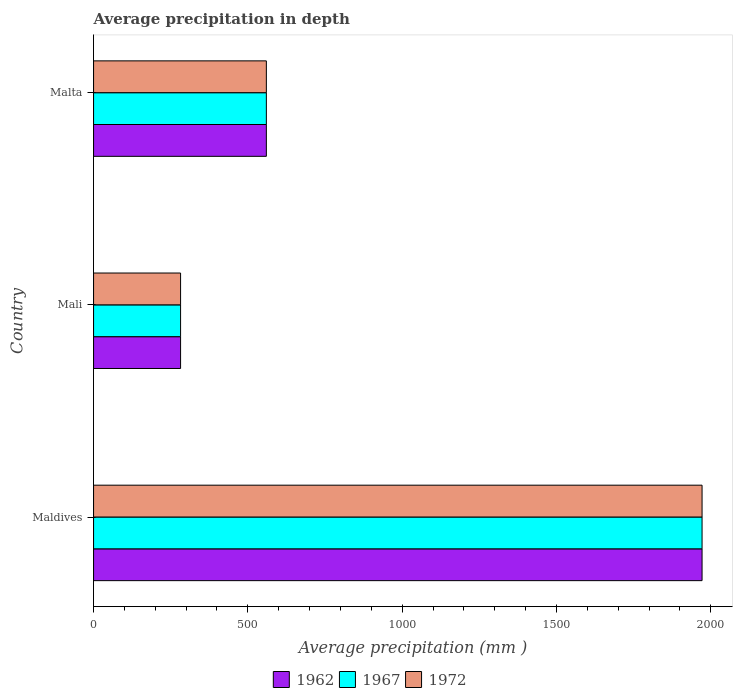Are the number of bars per tick equal to the number of legend labels?
Provide a short and direct response. Yes. How many bars are there on the 2nd tick from the top?
Make the answer very short. 3. How many bars are there on the 1st tick from the bottom?
Provide a succinct answer. 3. What is the label of the 3rd group of bars from the top?
Your answer should be compact. Maldives. What is the average precipitation in 1972 in Maldives?
Your response must be concise. 1972. Across all countries, what is the maximum average precipitation in 1972?
Your response must be concise. 1972. Across all countries, what is the minimum average precipitation in 1972?
Offer a very short reply. 282. In which country was the average precipitation in 1962 maximum?
Offer a terse response. Maldives. In which country was the average precipitation in 1967 minimum?
Offer a very short reply. Mali. What is the total average precipitation in 1962 in the graph?
Offer a very short reply. 2814. What is the difference between the average precipitation in 1967 in Maldives and that in Malta?
Provide a succinct answer. 1412. What is the difference between the average precipitation in 1972 in Malta and the average precipitation in 1962 in Maldives?
Ensure brevity in your answer.  -1412. What is the average average precipitation in 1967 per country?
Keep it short and to the point. 938. What is the difference between the average precipitation in 1972 and average precipitation in 1962 in Malta?
Provide a short and direct response. 0. What is the ratio of the average precipitation in 1962 in Maldives to that in Malta?
Offer a very short reply. 3.52. Is the average precipitation in 1962 in Maldives less than that in Malta?
Offer a very short reply. No. Is the difference between the average precipitation in 1972 in Maldives and Malta greater than the difference between the average precipitation in 1962 in Maldives and Malta?
Your answer should be compact. No. What is the difference between the highest and the second highest average precipitation in 1967?
Your response must be concise. 1412. What is the difference between the highest and the lowest average precipitation in 1962?
Your answer should be very brief. 1690. In how many countries, is the average precipitation in 1967 greater than the average average precipitation in 1967 taken over all countries?
Your response must be concise. 1. Is the sum of the average precipitation in 1962 in Maldives and Malta greater than the maximum average precipitation in 1967 across all countries?
Keep it short and to the point. Yes. What does the 3rd bar from the top in Malta represents?
Provide a succinct answer. 1962. Is it the case that in every country, the sum of the average precipitation in 1972 and average precipitation in 1967 is greater than the average precipitation in 1962?
Ensure brevity in your answer.  Yes. How many bars are there?
Give a very brief answer. 9. Are all the bars in the graph horizontal?
Ensure brevity in your answer.  Yes. Are the values on the major ticks of X-axis written in scientific E-notation?
Offer a very short reply. No. Does the graph contain any zero values?
Your answer should be very brief. No. How many legend labels are there?
Ensure brevity in your answer.  3. How are the legend labels stacked?
Your answer should be compact. Horizontal. What is the title of the graph?
Offer a terse response. Average precipitation in depth. Does "2014" appear as one of the legend labels in the graph?
Make the answer very short. No. What is the label or title of the X-axis?
Make the answer very short. Average precipitation (mm ). What is the Average precipitation (mm ) in 1962 in Maldives?
Your answer should be very brief. 1972. What is the Average precipitation (mm ) in 1967 in Maldives?
Provide a short and direct response. 1972. What is the Average precipitation (mm ) of 1972 in Maldives?
Your response must be concise. 1972. What is the Average precipitation (mm ) of 1962 in Mali?
Your answer should be very brief. 282. What is the Average precipitation (mm ) in 1967 in Mali?
Your answer should be very brief. 282. What is the Average precipitation (mm ) of 1972 in Mali?
Keep it short and to the point. 282. What is the Average precipitation (mm ) in 1962 in Malta?
Your response must be concise. 560. What is the Average precipitation (mm ) of 1967 in Malta?
Your answer should be compact. 560. What is the Average precipitation (mm ) in 1972 in Malta?
Offer a very short reply. 560. Across all countries, what is the maximum Average precipitation (mm ) in 1962?
Your answer should be very brief. 1972. Across all countries, what is the maximum Average precipitation (mm ) of 1967?
Offer a terse response. 1972. Across all countries, what is the maximum Average precipitation (mm ) of 1972?
Keep it short and to the point. 1972. Across all countries, what is the minimum Average precipitation (mm ) in 1962?
Provide a succinct answer. 282. Across all countries, what is the minimum Average precipitation (mm ) of 1967?
Keep it short and to the point. 282. Across all countries, what is the minimum Average precipitation (mm ) in 1972?
Your answer should be very brief. 282. What is the total Average precipitation (mm ) of 1962 in the graph?
Ensure brevity in your answer.  2814. What is the total Average precipitation (mm ) in 1967 in the graph?
Your answer should be very brief. 2814. What is the total Average precipitation (mm ) in 1972 in the graph?
Offer a terse response. 2814. What is the difference between the Average precipitation (mm ) in 1962 in Maldives and that in Mali?
Offer a very short reply. 1690. What is the difference between the Average precipitation (mm ) of 1967 in Maldives and that in Mali?
Make the answer very short. 1690. What is the difference between the Average precipitation (mm ) of 1972 in Maldives and that in Mali?
Provide a short and direct response. 1690. What is the difference between the Average precipitation (mm ) of 1962 in Maldives and that in Malta?
Your answer should be compact. 1412. What is the difference between the Average precipitation (mm ) in 1967 in Maldives and that in Malta?
Provide a succinct answer. 1412. What is the difference between the Average precipitation (mm ) of 1972 in Maldives and that in Malta?
Offer a very short reply. 1412. What is the difference between the Average precipitation (mm ) of 1962 in Mali and that in Malta?
Offer a very short reply. -278. What is the difference between the Average precipitation (mm ) in 1967 in Mali and that in Malta?
Offer a terse response. -278. What is the difference between the Average precipitation (mm ) in 1972 in Mali and that in Malta?
Your answer should be very brief. -278. What is the difference between the Average precipitation (mm ) of 1962 in Maldives and the Average precipitation (mm ) of 1967 in Mali?
Your answer should be compact. 1690. What is the difference between the Average precipitation (mm ) of 1962 in Maldives and the Average precipitation (mm ) of 1972 in Mali?
Provide a short and direct response. 1690. What is the difference between the Average precipitation (mm ) in 1967 in Maldives and the Average precipitation (mm ) in 1972 in Mali?
Your answer should be very brief. 1690. What is the difference between the Average precipitation (mm ) of 1962 in Maldives and the Average precipitation (mm ) of 1967 in Malta?
Provide a succinct answer. 1412. What is the difference between the Average precipitation (mm ) of 1962 in Maldives and the Average precipitation (mm ) of 1972 in Malta?
Give a very brief answer. 1412. What is the difference between the Average precipitation (mm ) of 1967 in Maldives and the Average precipitation (mm ) of 1972 in Malta?
Offer a terse response. 1412. What is the difference between the Average precipitation (mm ) of 1962 in Mali and the Average precipitation (mm ) of 1967 in Malta?
Your response must be concise. -278. What is the difference between the Average precipitation (mm ) of 1962 in Mali and the Average precipitation (mm ) of 1972 in Malta?
Your response must be concise. -278. What is the difference between the Average precipitation (mm ) in 1967 in Mali and the Average precipitation (mm ) in 1972 in Malta?
Give a very brief answer. -278. What is the average Average precipitation (mm ) in 1962 per country?
Your answer should be very brief. 938. What is the average Average precipitation (mm ) in 1967 per country?
Give a very brief answer. 938. What is the average Average precipitation (mm ) of 1972 per country?
Your answer should be compact. 938. What is the difference between the Average precipitation (mm ) in 1962 and Average precipitation (mm ) in 1967 in Maldives?
Provide a succinct answer. 0. What is the difference between the Average precipitation (mm ) in 1967 and Average precipitation (mm ) in 1972 in Mali?
Make the answer very short. 0. What is the difference between the Average precipitation (mm ) in 1967 and Average precipitation (mm ) in 1972 in Malta?
Ensure brevity in your answer.  0. What is the ratio of the Average precipitation (mm ) of 1962 in Maldives to that in Mali?
Your answer should be compact. 6.99. What is the ratio of the Average precipitation (mm ) of 1967 in Maldives to that in Mali?
Provide a succinct answer. 6.99. What is the ratio of the Average precipitation (mm ) in 1972 in Maldives to that in Mali?
Keep it short and to the point. 6.99. What is the ratio of the Average precipitation (mm ) in 1962 in Maldives to that in Malta?
Offer a very short reply. 3.52. What is the ratio of the Average precipitation (mm ) in 1967 in Maldives to that in Malta?
Give a very brief answer. 3.52. What is the ratio of the Average precipitation (mm ) of 1972 in Maldives to that in Malta?
Ensure brevity in your answer.  3.52. What is the ratio of the Average precipitation (mm ) in 1962 in Mali to that in Malta?
Keep it short and to the point. 0.5. What is the ratio of the Average precipitation (mm ) of 1967 in Mali to that in Malta?
Provide a succinct answer. 0.5. What is the ratio of the Average precipitation (mm ) in 1972 in Mali to that in Malta?
Provide a succinct answer. 0.5. What is the difference between the highest and the second highest Average precipitation (mm ) in 1962?
Your response must be concise. 1412. What is the difference between the highest and the second highest Average precipitation (mm ) of 1967?
Give a very brief answer. 1412. What is the difference between the highest and the second highest Average precipitation (mm ) in 1972?
Provide a succinct answer. 1412. What is the difference between the highest and the lowest Average precipitation (mm ) of 1962?
Provide a short and direct response. 1690. What is the difference between the highest and the lowest Average precipitation (mm ) in 1967?
Offer a very short reply. 1690. What is the difference between the highest and the lowest Average precipitation (mm ) in 1972?
Provide a succinct answer. 1690. 